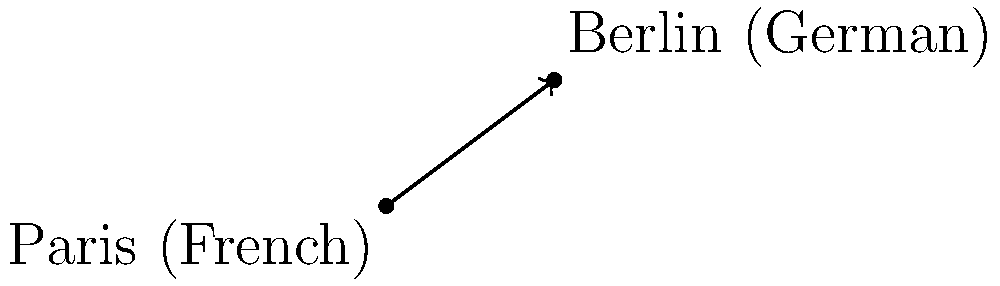As a polyglot backpacker, you're planning a trip from Paris to Berlin. On a 2D coordinate plane, Paris (primarily French-speaking) is located at (0, 0), and Berlin (primarily German-speaking) is at (8, 6), where each unit represents 100 km. Calculate the direct distance between these two linguistically diverse cities. To find the distance between Paris and Berlin, we can use the distance formula derived from the Pythagorean theorem:

1) The distance formula is: $d = \sqrt{(x_2 - x_1)^2 + (y_2 - y_1)^2}$

2) We have:
   Paris (x₁, y₁) = (0, 0)
   Berlin (x₂, y₂) = (8, 6)

3) Plugging these into the formula:
   $d = \sqrt{(8 - 0)^2 + (6 - 0)^2}$

4) Simplify:
   $d = \sqrt{8^2 + 6^2}$
   $d = \sqrt{64 + 36}$
   $d = \sqrt{100}$
   $d = 10$

5) Since each unit represents 100 km:
   Actual distance = 10 * 100 = 1000 km

Therefore, the direct distance between Paris and Berlin is 1000 km.
Answer: 1000 km 